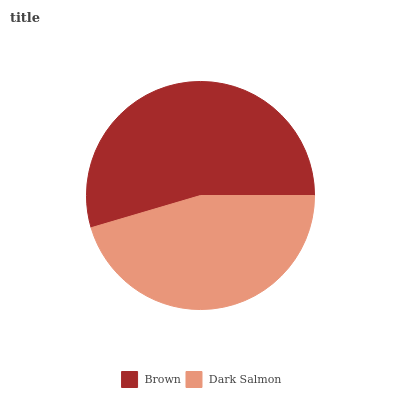Is Dark Salmon the minimum?
Answer yes or no. Yes. Is Brown the maximum?
Answer yes or no. Yes. Is Dark Salmon the maximum?
Answer yes or no. No. Is Brown greater than Dark Salmon?
Answer yes or no. Yes. Is Dark Salmon less than Brown?
Answer yes or no. Yes. Is Dark Salmon greater than Brown?
Answer yes or no. No. Is Brown less than Dark Salmon?
Answer yes or no. No. Is Brown the high median?
Answer yes or no. Yes. Is Dark Salmon the low median?
Answer yes or no. Yes. Is Dark Salmon the high median?
Answer yes or no. No. Is Brown the low median?
Answer yes or no. No. 